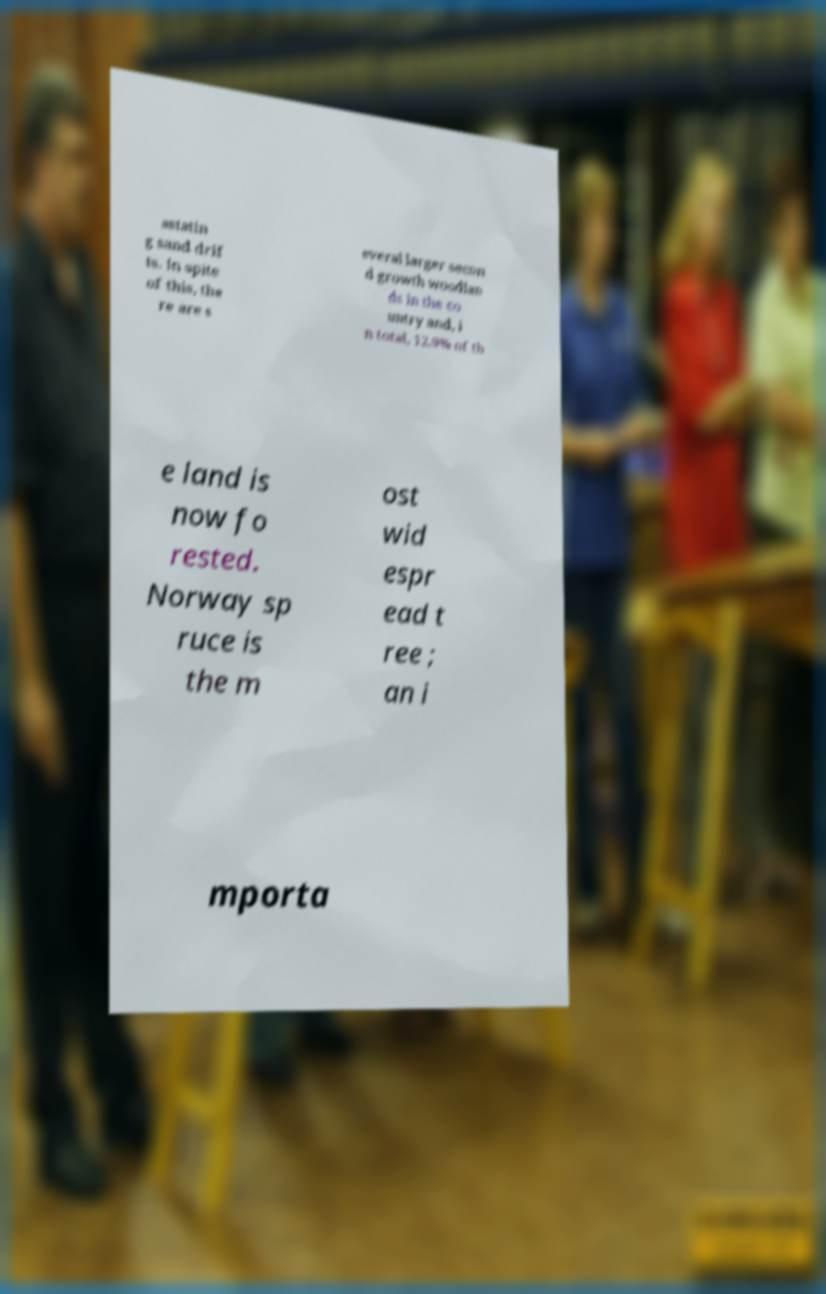Can you read and provide the text displayed in the image?This photo seems to have some interesting text. Can you extract and type it out for me? astatin g sand drif ts. In spite of this, the re are s everal larger secon d growth woodlan ds in the co untry and, i n total, 12.9% of th e land is now fo rested. Norway sp ruce is the m ost wid espr ead t ree ; an i mporta 